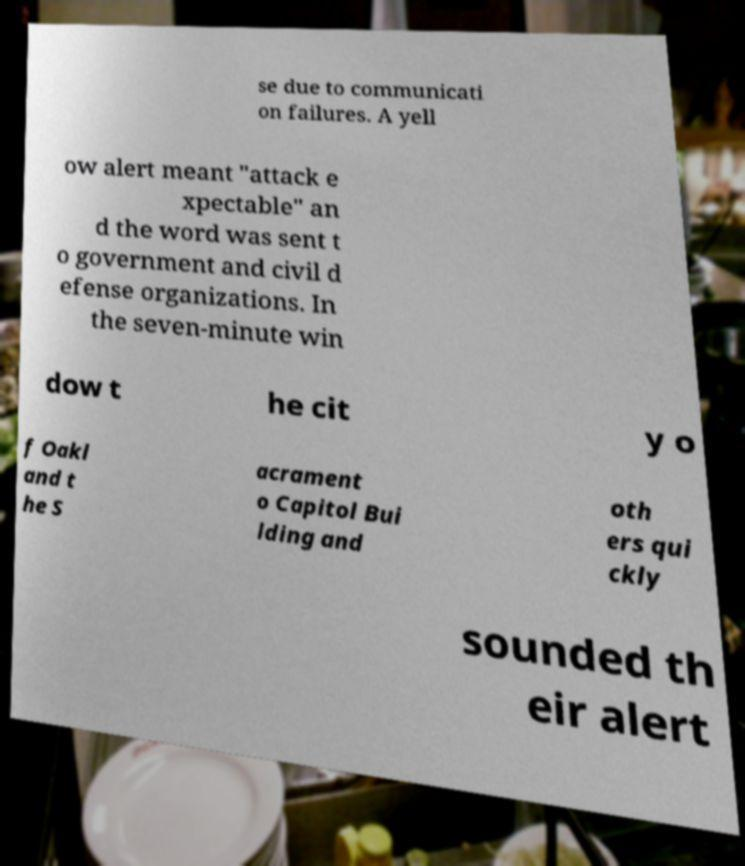Please identify and transcribe the text found in this image. se due to communicati on failures. A yell ow alert meant "attack e xpectable" an d the word was sent t o government and civil d efense organizations. In the seven-minute win dow t he cit y o f Oakl and t he S acrament o Capitol Bui lding and oth ers qui ckly sounded th eir alert 